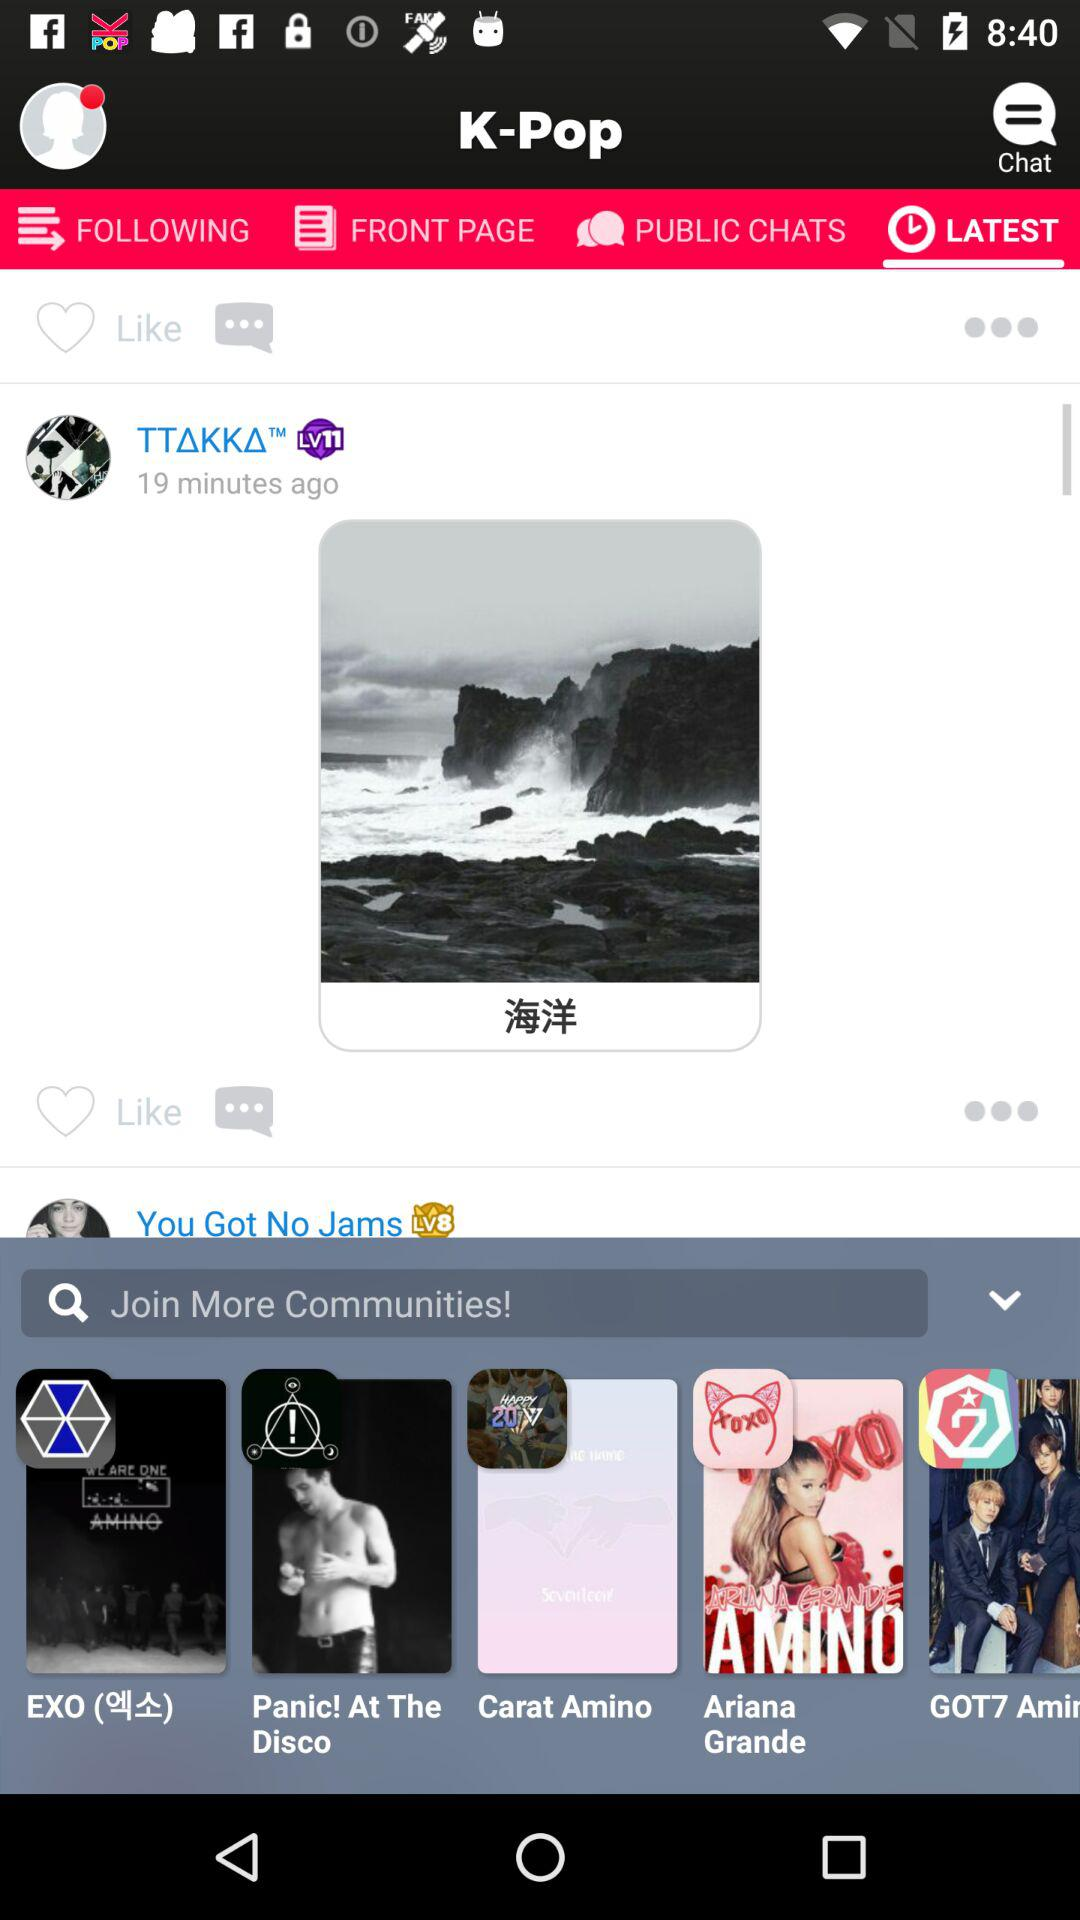Which tab is selected? The selected tab is "LATEST". 